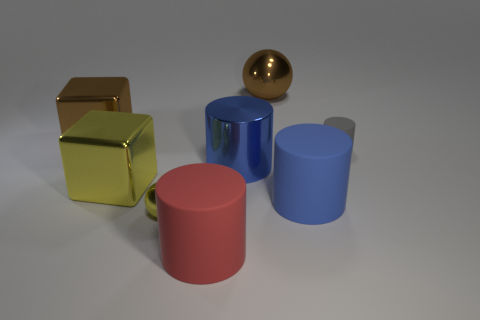Could you describe the lighting in the room where these objects are placed? Certainly, the ambient lighting in this scene suggests a soft, diffused source of light coming from above, producing subtle shadows – indicating the objects are likely indoors with an artificial light source not directly visible in the frame. How might the lighting affect the appearance of these objects? The diffuse lighting enhances the objects' appearance by softening shadows and highlights, which brings out the colors and surface textures of the objects without creating harsh reflections or deep shadows that might obscure their shapes. 